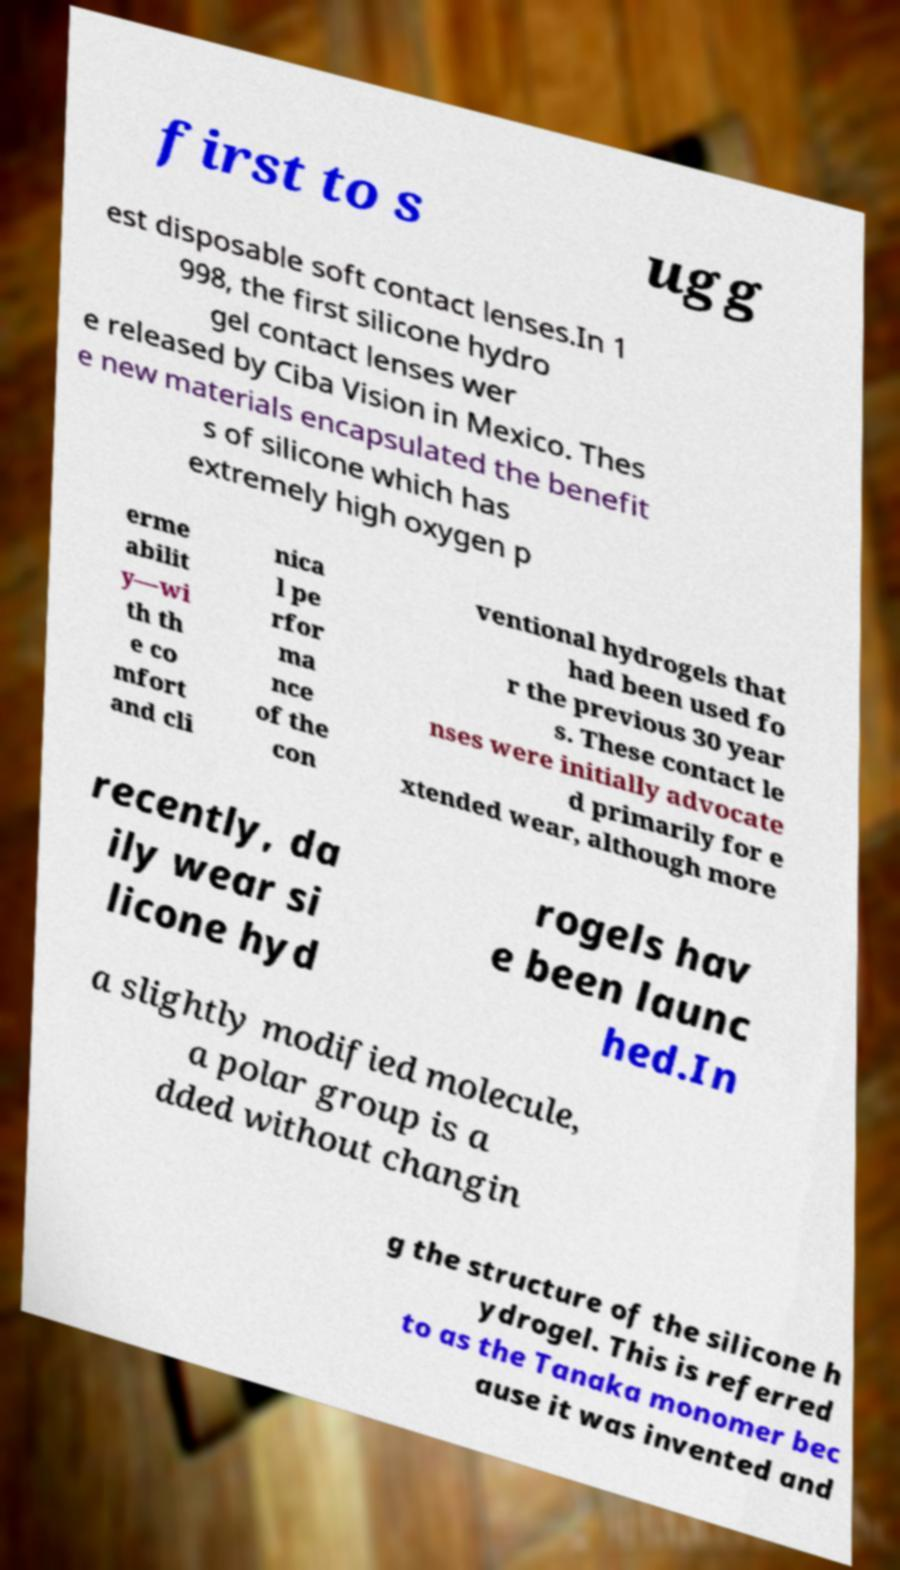What messages or text are displayed in this image? I need them in a readable, typed format. first to s ugg est disposable soft contact lenses.In 1 998, the first silicone hydro gel contact lenses wer e released by Ciba Vision in Mexico. Thes e new materials encapsulated the benefit s of silicone which has extremely high oxygen p erme abilit y—wi th th e co mfort and cli nica l pe rfor ma nce of the con ventional hydrogels that had been used fo r the previous 30 year s. These contact le nses were initially advocate d primarily for e xtended wear, although more recently, da ily wear si licone hyd rogels hav e been launc hed.In a slightly modified molecule, a polar group is a dded without changin g the structure of the silicone h ydrogel. This is referred to as the Tanaka monomer bec ause it was invented and 